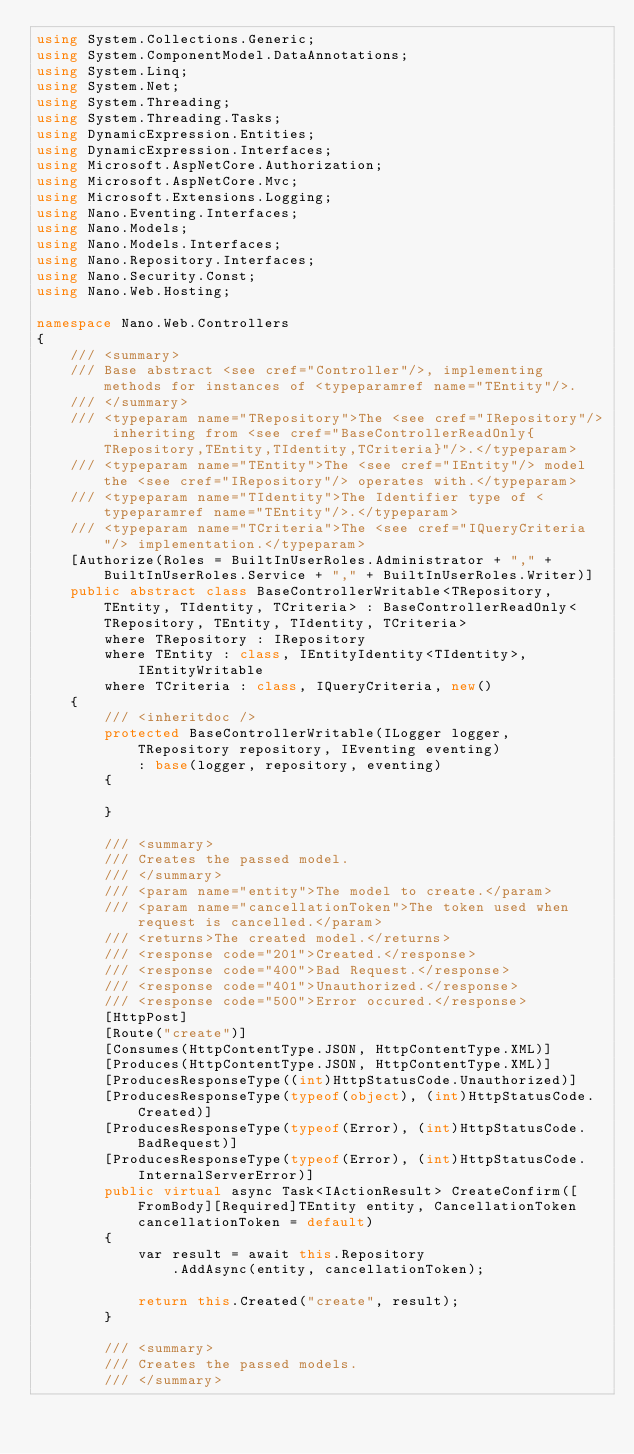Convert code to text. <code><loc_0><loc_0><loc_500><loc_500><_C#_>using System.Collections.Generic;
using System.ComponentModel.DataAnnotations;
using System.Linq;
using System.Net;
using System.Threading;
using System.Threading.Tasks;
using DynamicExpression.Entities;
using DynamicExpression.Interfaces;
using Microsoft.AspNetCore.Authorization;
using Microsoft.AspNetCore.Mvc;
using Microsoft.Extensions.Logging;
using Nano.Eventing.Interfaces;
using Nano.Models;
using Nano.Models.Interfaces;
using Nano.Repository.Interfaces;
using Nano.Security.Const;
using Nano.Web.Hosting;

namespace Nano.Web.Controllers
{
    /// <summary>
    /// Base abstract <see cref="Controller"/>, implementing  methods for instances of <typeparamref name="TEntity"/>.
    /// </summary>
    /// <typeparam name="TRepository">The <see cref="IRepository"/> inheriting from <see cref="BaseControllerReadOnly{TRepository,TEntity,TIdentity,TCriteria}"/>.</typeparam>
    /// <typeparam name="TEntity">The <see cref="IEntity"/> model the <see cref="IRepository"/> operates with.</typeparam>
    /// <typeparam name="TIdentity">The Identifier type of <typeparamref name="TEntity"/>.</typeparam>
    /// <typeparam name="TCriteria">The <see cref="IQueryCriteria"/> implementation.</typeparam>
    [Authorize(Roles = BuiltInUserRoles.Administrator + "," + BuiltInUserRoles.Service + "," + BuiltInUserRoles.Writer)]
    public abstract class BaseControllerWritable<TRepository, TEntity, TIdentity, TCriteria> : BaseControllerReadOnly<TRepository, TEntity, TIdentity, TCriteria>
        where TRepository : IRepository
        where TEntity : class, IEntityIdentity<TIdentity>, IEntityWritable
        where TCriteria : class, IQueryCriteria, new()
    {
        /// <inheritdoc />
        protected BaseControllerWritable(ILogger logger, TRepository repository, IEventing eventing)
            : base(logger, repository, eventing)
        {

        }

        /// <summary>
        /// Creates the passed model.
        /// </summary>
        /// <param name="entity">The model to create.</param>
        /// <param name="cancellationToken">The token used when request is cancelled.</param>
        /// <returns>The created model.</returns>
        /// <response code="201">Created.</response>
        /// <response code="400">Bad Request.</response>
        /// <response code="401">Unauthorized.</response>
        /// <response code="500">Error occured.</response>
        [HttpPost]
        [Route("create")]
        [Consumes(HttpContentType.JSON, HttpContentType.XML)]
        [Produces(HttpContentType.JSON, HttpContentType.XML)]
        [ProducesResponseType((int)HttpStatusCode.Unauthorized)]
        [ProducesResponseType(typeof(object), (int)HttpStatusCode.Created)]
        [ProducesResponseType(typeof(Error), (int)HttpStatusCode.BadRequest)]
        [ProducesResponseType(typeof(Error), (int)HttpStatusCode.InternalServerError)]
        public virtual async Task<IActionResult> CreateConfirm([FromBody][Required]TEntity entity, CancellationToken cancellationToken = default)
        {
            var result = await this.Repository
                .AddAsync(entity, cancellationToken);

            return this.Created("create", result);
        }

        /// <summary>
        /// Creates the passed models.
        /// </summary></code> 